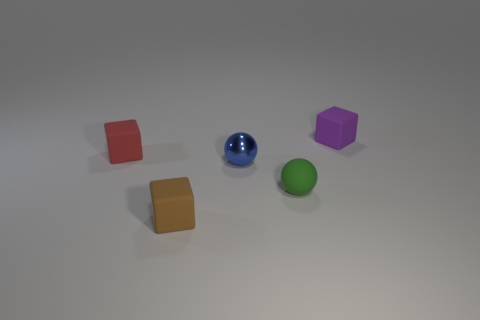Subtract all small brown rubber blocks. How many blocks are left? 2 Subtract all brown blocks. How many blocks are left? 2 Add 3 brown cubes. How many objects exist? 8 Subtract all cubes. How many objects are left? 2 Subtract all blue shiny objects. Subtract all tiny rubber balls. How many objects are left? 3 Add 3 shiny objects. How many shiny objects are left? 4 Add 2 gray shiny cubes. How many gray shiny cubes exist? 2 Subtract 0 gray cylinders. How many objects are left? 5 Subtract 2 cubes. How many cubes are left? 1 Subtract all blue cubes. Subtract all gray balls. How many cubes are left? 3 